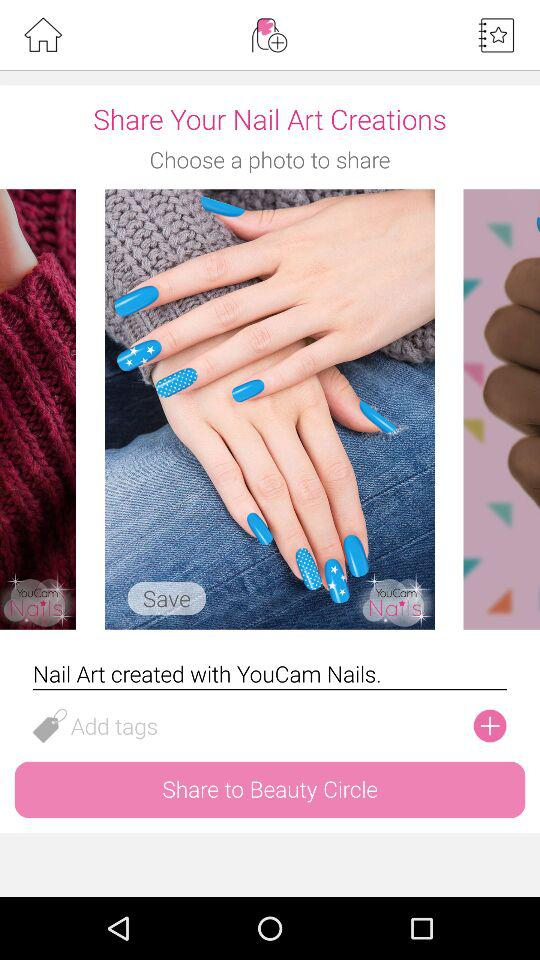Which photo is selected to share with others?
When the provided information is insufficient, respond with <no answer>. <no answer> 